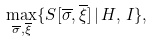<formula> <loc_0><loc_0><loc_500><loc_500>\max _ { \overline { \sigma } , \overline { \xi } } \{ { S } [ \overline { \sigma } , \overline { \xi } ] \, | \, H , \, I \} ,</formula> 